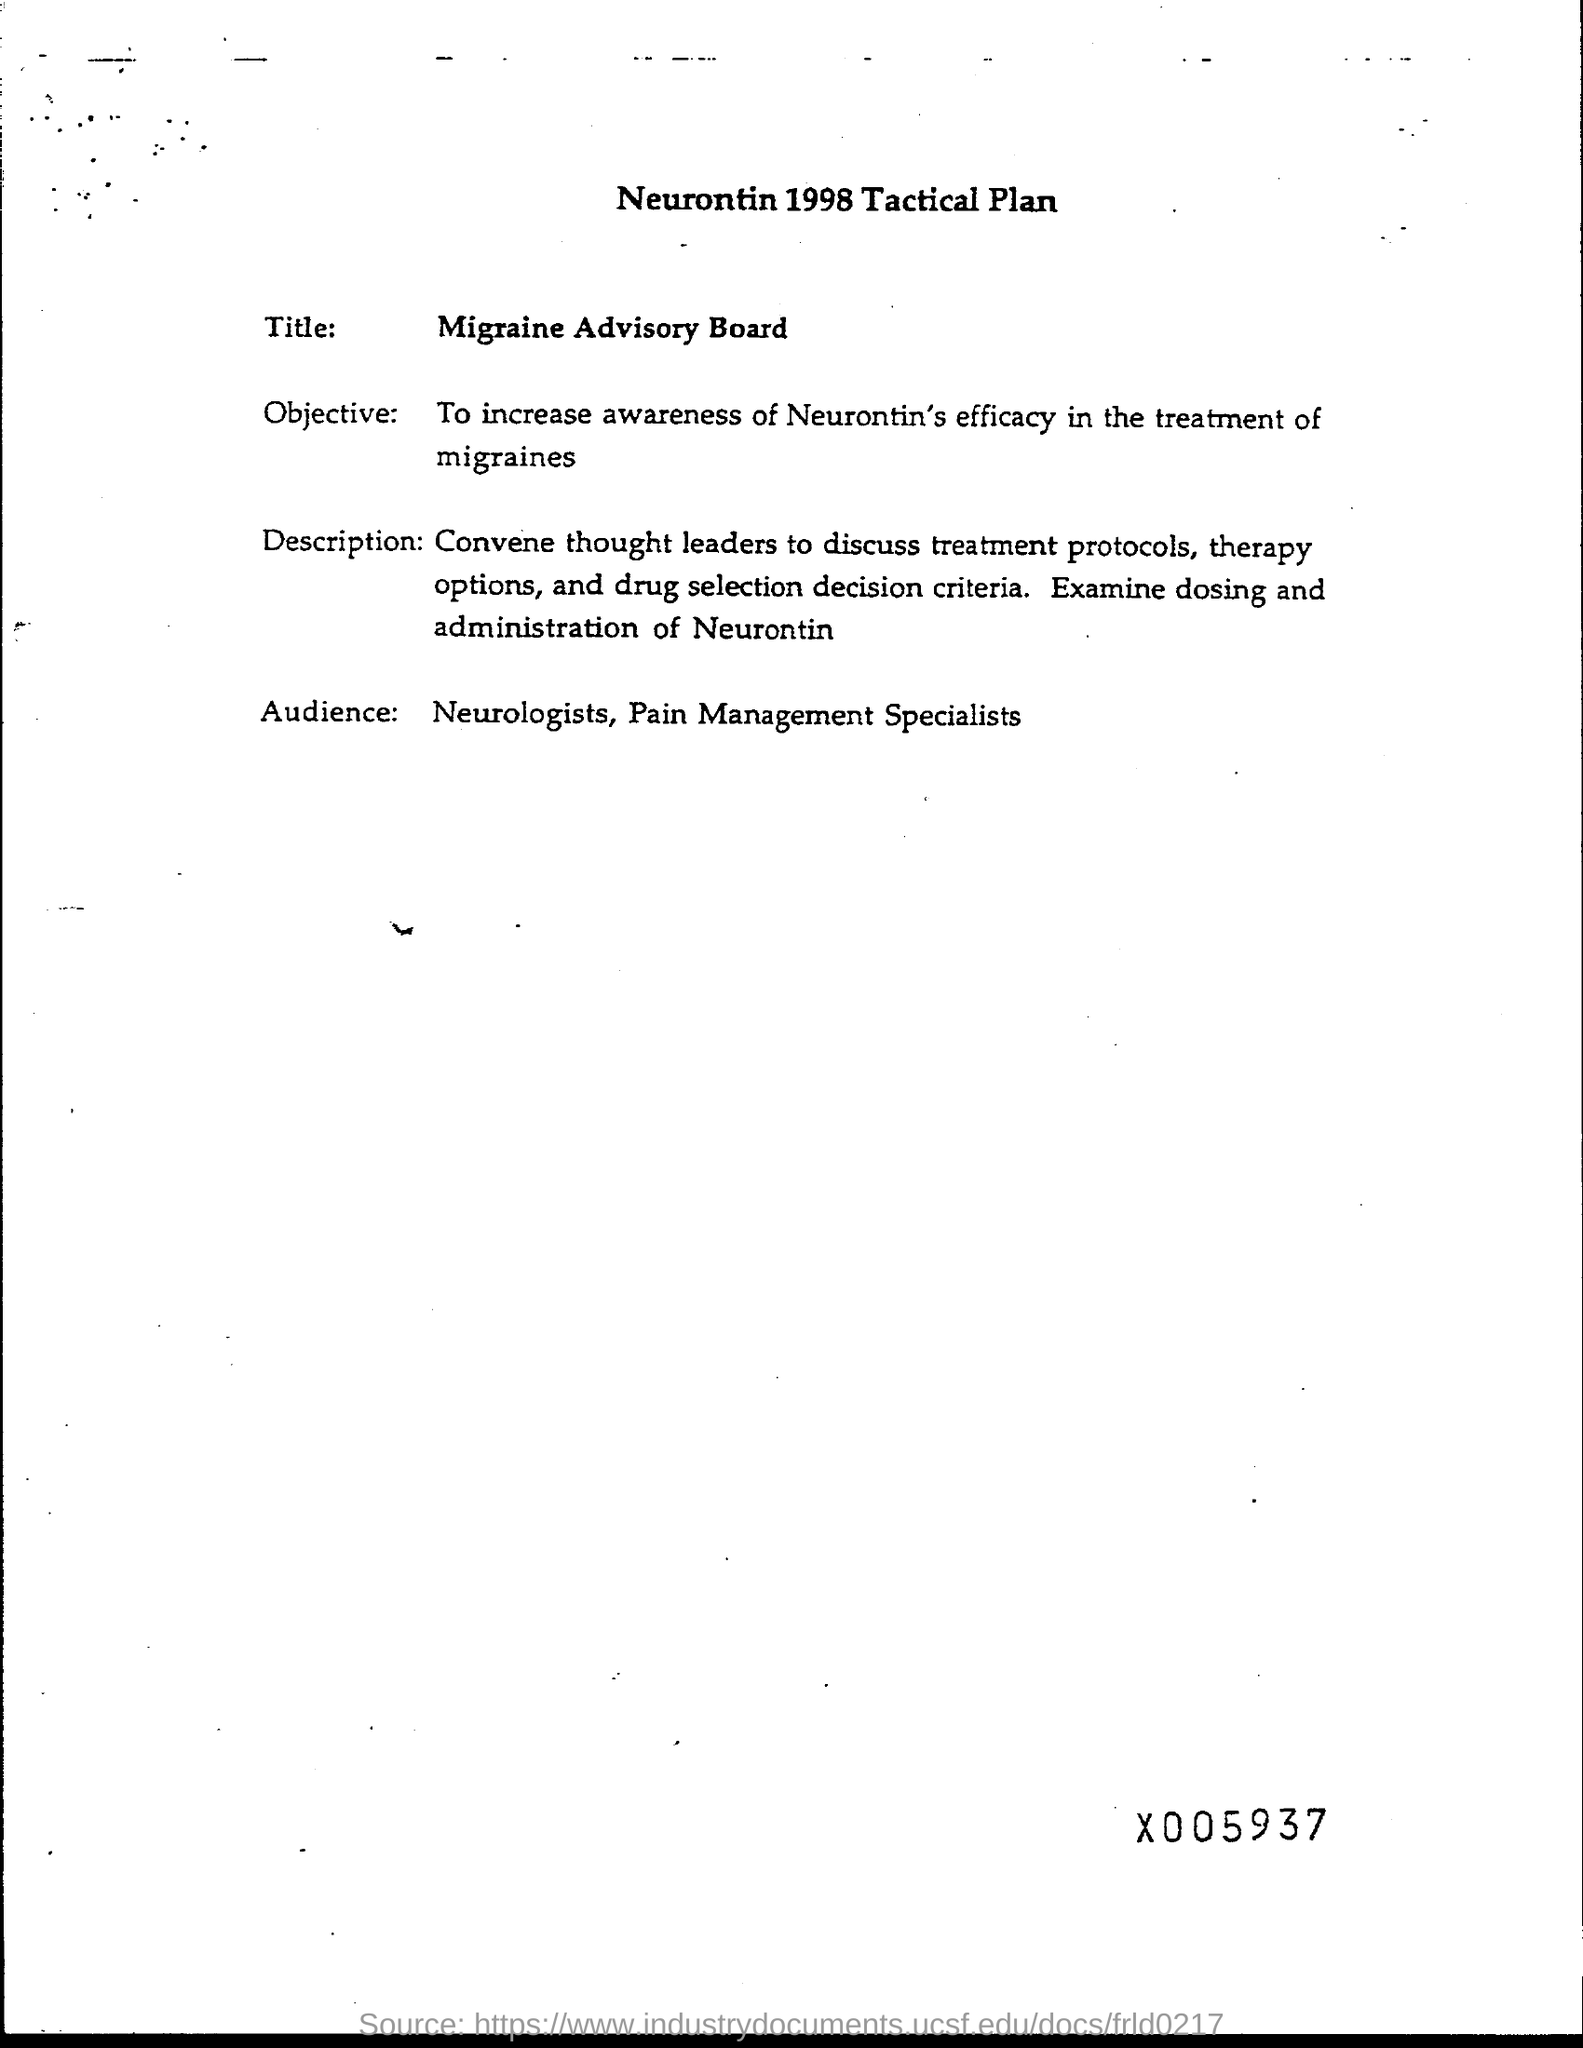What is the year mentioned in the heading of the document?
Offer a terse response. 1998. What is the heading?
Provide a succinct answer. Neurontin 1998 Tactical Plan. What awareness is to be increased in the treatment of migraines?
Give a very brief answer. Neurontin's efficacy. Who are the Audience?
Offer a very short reply. Neurologists, Pain Management Specialists. 